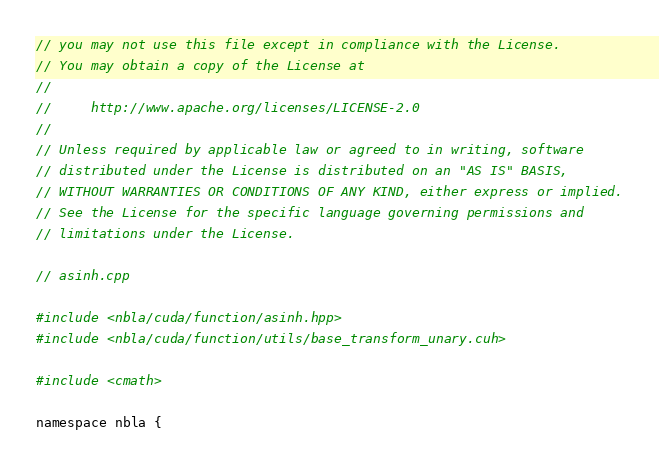<code> <loc_0><loc_0><loc_500><loc_500><_Cuda_>// you may not use this file except in compliance with the License.
// You may obtain a copy of the License at
//
//     http://www.apache.org/licenses/LICENSE-2.0
//
// Unless required by applicable law or agreed to in writing, software
// distributed under the License is distributed on an "AS IS" BASIS,
// WITHOUT WARRANTIES OR CONDITIONS OF ANY KIND, either express or implied.
// See the License for the specific language governing permissions and
// limitations under the License.

// asinh.cpp

#include <nbla/cuda/function/asinh.hpp>
#include <nbla/cuda/function/utils/base_transform_unary.cuh>

#include <cmath>

namespace nbla {
</code> 